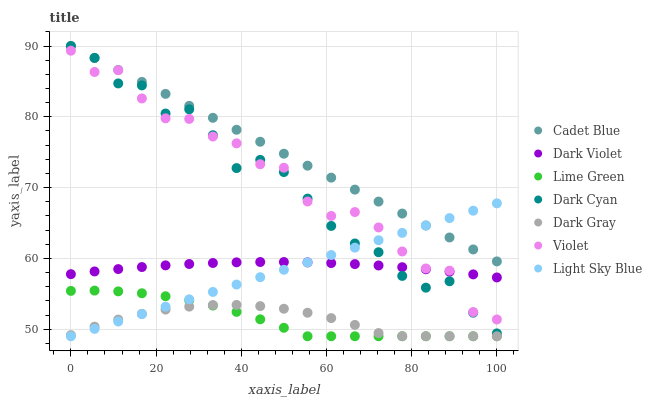Does Dark Gray have the minimum area under the curve?
Answer yes or no. Yes. Does Cadet Blue have the maximum area under the curve?
Answer yes or no. Yes. Does Dark Violet have the minimum area under the curve?
Answer yes or no. No. Does Dark Violet have the maximum area under the curve?
Answer yes or no. No. Is Light Sky Blue the smoothest?
Answer yes or no. Yes. Is Violet the roughest?
Answer yes or no. Yes. Is Dark Violet the smoothest?
Answer yes or no. No. Is Dark Violet the roughest?
Answer yes or no. No. Does Dark Gray have the lowest value?
Answer yes or no. Yes. Does Dark Violet have the lowest value?
Answer yes or no. No. Does Dark Cyan have the highest value?
Answer yes or no. Yes. Does Dark Violet have the highest value?
Answer yes or no. No. Is Violet less than Cadet Blue?
Answer yes or no. Yes. Is Cadet Blue greater than Lime Green?
Answer yes or no. Yes. Does Lime Green intersect Dark Gray?
Answer yes or no. Yes. Is Lime Green less than Dark Gray?
Answer yes or no. No. Is Lime Green greater than Dark Gray?
Answer yes or no. No. Does Violet intersect Cadet Blue?
Answer yes or no. No. 